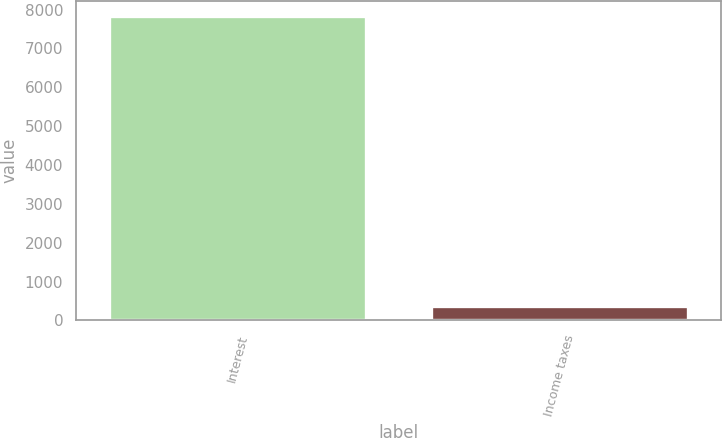Convert chart to OTSL. <chart><loc_0><loc_0><loc_500><loc_500><bar_chart><fcel>Interest<fcel>Income taxes<nl><fcel>7825<fcel>382<nl></chart> 